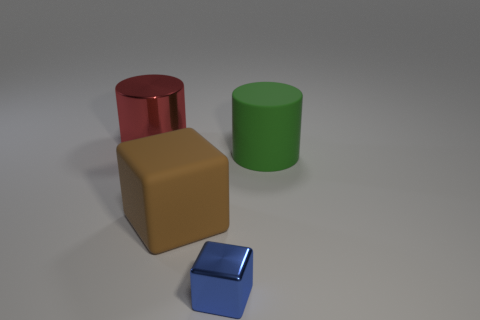What is the color of the other big object that is the same shape as the green thing?
Provide a short and direct response. Red. Is there another rubber object of the same shape as the small blue thing?
Your answer should be very brief. Yes. What size is the thing that is both behind the matte cube and to the left of the green thing?
Offer a very short reply. Large. There is a red object that is the same size as the brown cube; what is its material?
Your answer should be very brief. Metal. Is there a matte cylinder of the same size as the green thing?
Provide a succinct answer. No. How many metallic objects are red things or brown objects?
Give a very brief answer. 1. What number of big objects are behind the large cylinder that is in front of the cylinder that is behind the green object?
Your response must be concise. 1. There is a green cylinder that is the same material as the big brown cube; what is its size?
Give a very brief answer. Large. What number of other small blocks have the same color as the matte cube?
Offer a terse response. 0. Is the size of the cylinder that is to the right of the rubber cube the same as the metallic cylinder?
Offer a very short reply. Yes. 